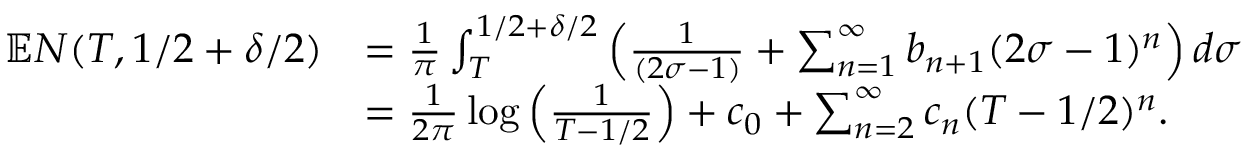<formula> <loc_0><loc_0><loc_500><loc_500>\begin{array} { r l } { \mathbb { E } N ( T , 1 / 2 + \delta / 2 ) } & { = \frac { 1 } { \pi } \int _ { T } ^ { 1 / 2 + \delta / 2 } \left ( \frac { 1 } { ( 2 \sigma - 1 ) } + \sum _ { n = 1 } ^ { \infty } b _ { n + 1 } ( 2 \sigma - 1 ) ^ { n } \right ) d \sigma } \\ & { = \frac { 1 } { 2 \pi } \log \left ( \frac { 1 } { T - 1 / 2 } \right ) + c _ { 0 } + \sum _ { n = 2 } ^ { \infty } c _ { n } ( T - 1 / 2 ) ^ { n } . } \end{array}</formula> 